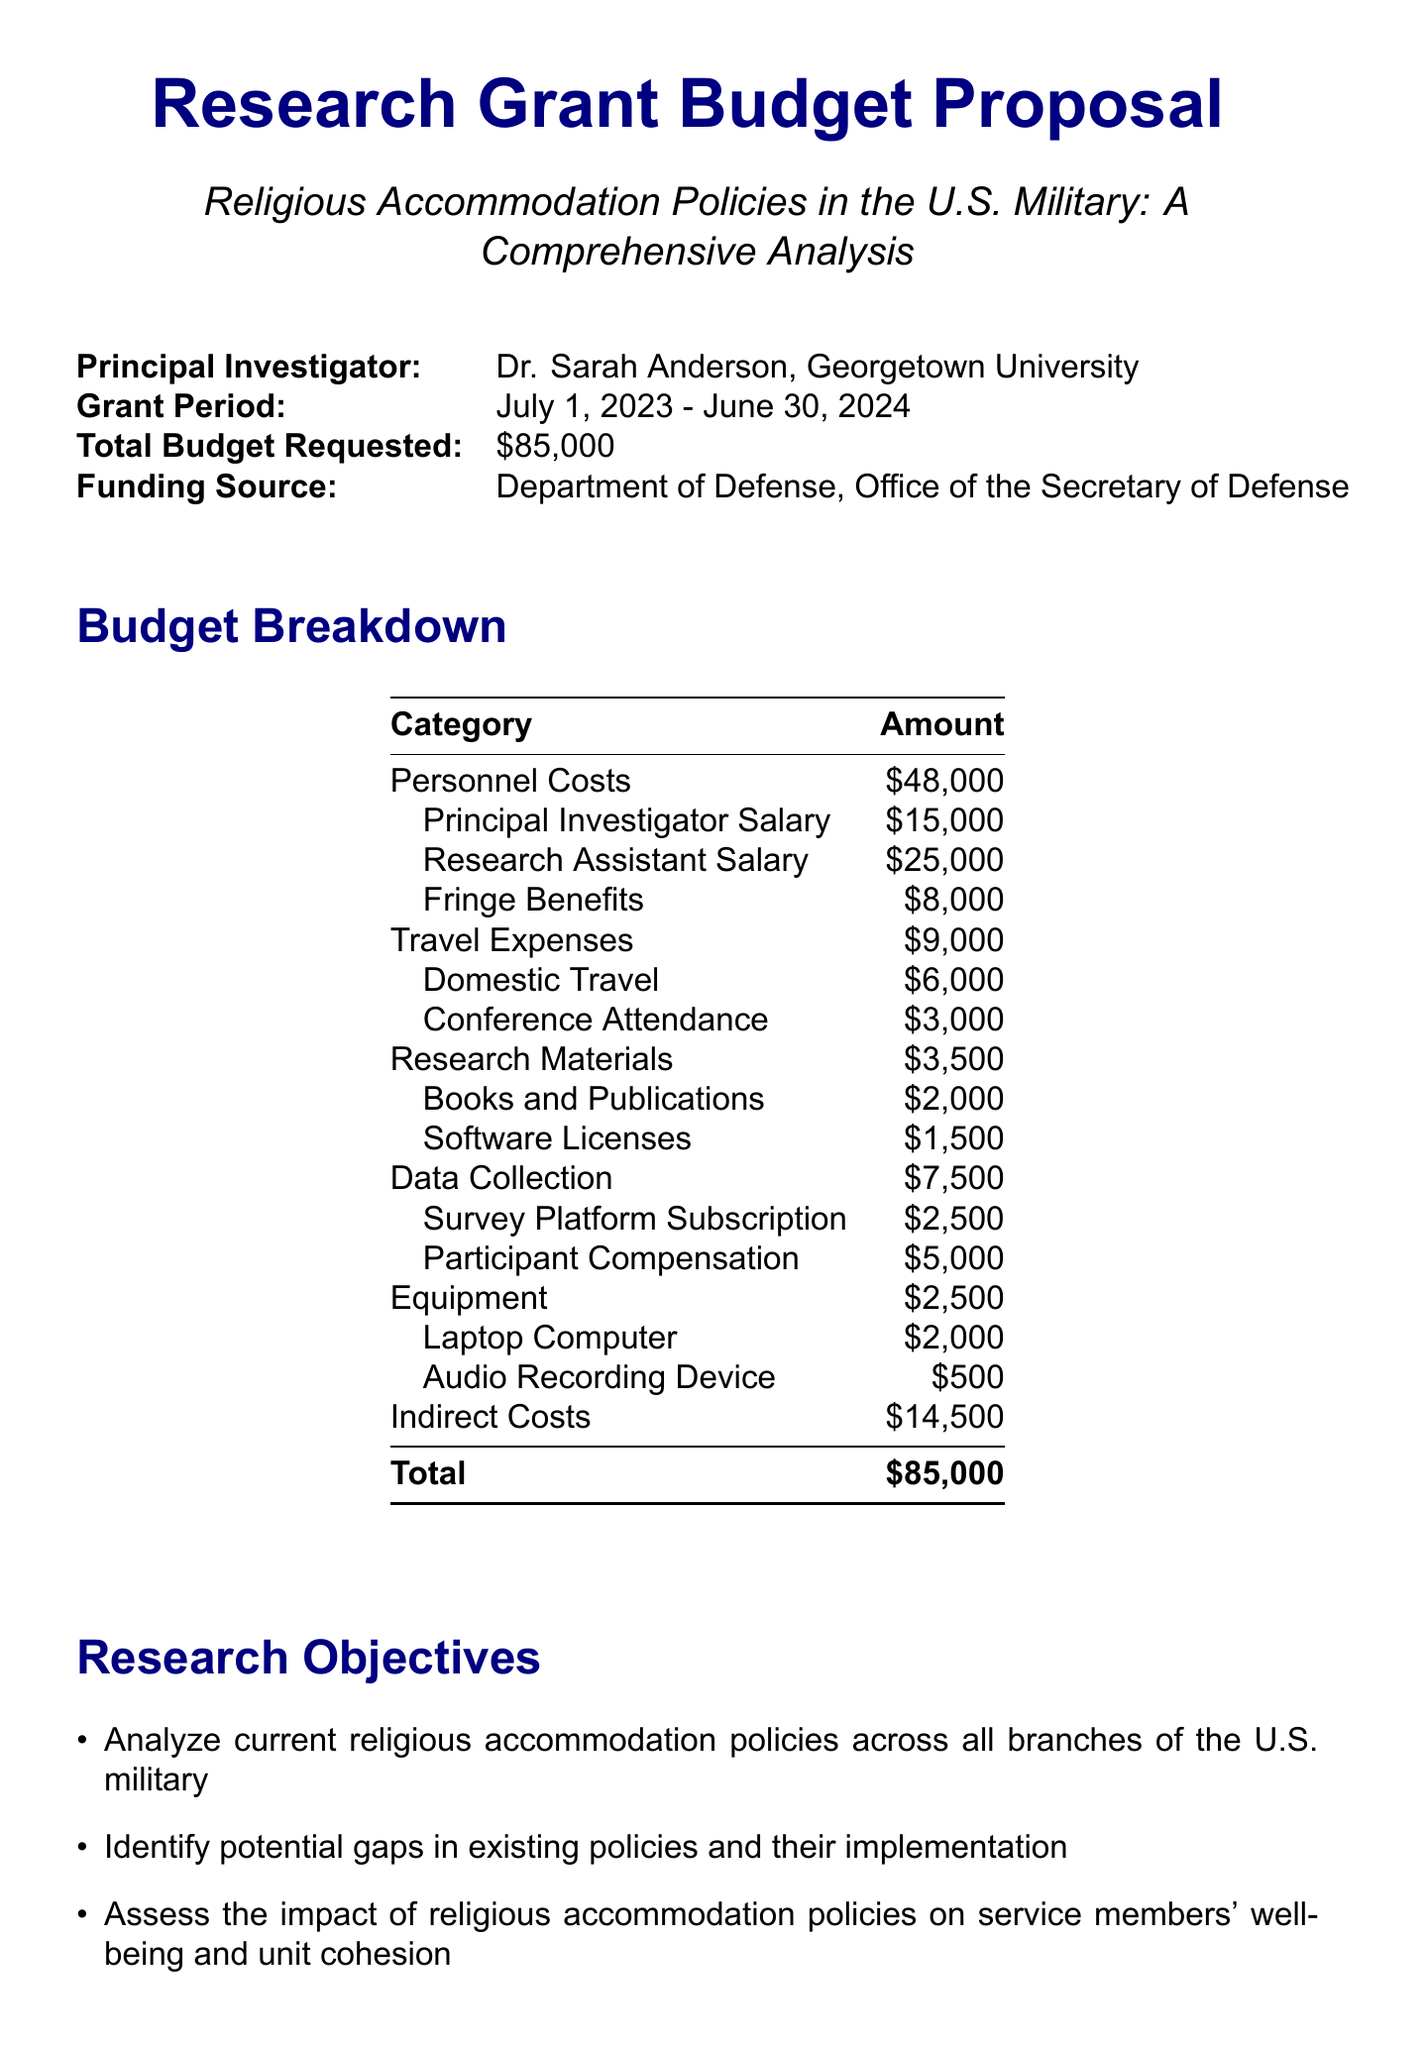What is the project title? The project title is provided at the beginning of the document.
Answer: Religious Accommodation Policies in the U.S. Military: A Comprehensive Analysis Who is the principal investigator? The name of the principal investigator is listed in the document.
Answer: Dr. Sarah Anderson, Associate Professor of Religious Studies, Georgetown University What is the total budget requested? The total budget requested is explicitly stated in the document.
Answer: $85,000 What are the amounts allocated for personnel costs? Personnel costs are broken down into specific components indicating salaries and benefits.
Answer: $48,000 What is the funding source for this research? The document specifies the entity providing the funding.
Answer: Department of Defense, Office of the Secretary of Defense How long is the grant period? The grant period is mentioned in the document detailing the start and end dates.
Answer: July 1, 2023 - June 30, 2024 What is one research objective mentioned in the document? The research objectives are listed in a bullet format.
Answer: Analyze current religious accommodation policies across all branches of the U.S. military What type of deliverable will be produced for military leadership? The deliverables section lists various outputs from the research.
Answer: Policy brief for military leadership and policymakers Which category has the highest budget allocation? By analyzing the budget breakdown, we can determine which category has the most funds.
Answer: Personnel Costs 